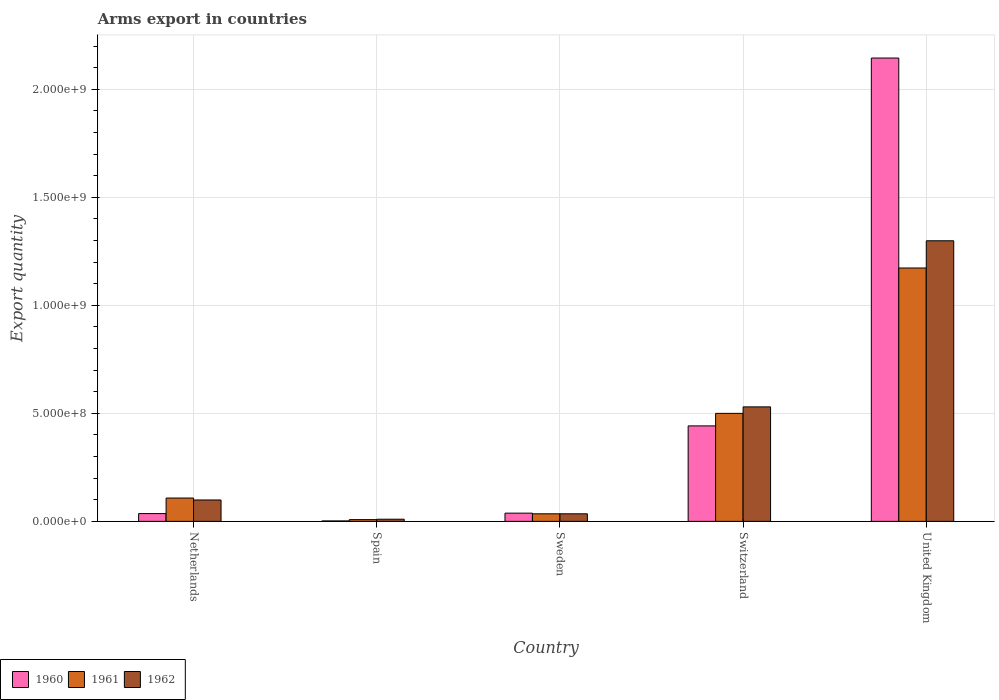How many different coloured bars are there?
Your answer should be compact. 3. How many groups of bars are there?
Provide a short and direct response. 5. Are the number of bars on each tick of the X-axis equal?
Make the answer very short. Yes. What is the label of the 1st group of bars from the left?
Ensure brevity in your answer.  Netherlands. In how many cases, is the number of bars for a given country not equal to the number of legend labels?
Your answer should be very brief. 0. What is the total arms export in 1961 in United Kingdom?
Your response must be concise. 1.17e+09. Across all countries, what is the maximum total arms export in 1962?
Your response must be concise. 1.30e+09. In which country was the total arms export in 1961 maximum?
Your response must be concise. United Kingdom. In which country was the total arms export in 1961 minimum?
Ensure brevity in your answer.  Spain. What is the total total arms export in 1962 in the graph?
Make the answer very short. 1.97e+09. What is the difference between the total arms export in 1960 in Spain and that in Switzerland?
Offer a very short reply. -4.40e+08. What is the difference between the total arms export in 1961 in Switzerland and the total arms export in 1962 in Netherlands?
Offer a terse response. 4.01e+08. What is the average total arms export in 1962 per country?
Your answer should be very brief. 3.95e+08. What is the difference between the total arms export of/in 1960 and total arms export of/in 1962 in Netherlands?
Offer a terse response. -6.30e+07. In how many countries, is the total arms export in 1960 greater than 300000000?
Your response must be concise. 2. What is the ratio of the total arms export in 1960 in Netherlands to that in United Kingdom?
Make the answer very short. 0.02. Is the total arms export in 1961 in Sweden less than that in Switzerland?
Offer a very short reply. Yes. Is the difference between the total arms export in 1960 in Sweden and United Kingdom greater than the difference between the total arms export in 1962 in Sweden and United Kingdom?
Offer a terse response. No. What is the difference between the highest and the second highest total arms export in 1962?
Provide a short and direct response. 7.69e+08. What is the difference between the highest and the lowest total arms export in 1960?
Make the answer very short. 2.14e+09. What does the 2nd bar from the left in Spain represents?
Your answer should be compact. 1961. What does the 1st bar from the right in Sweden represents?
Your answer should be very brief. 1962. Is it the case that in every country, the sum of the total arms export in 1961 and total arms export in 1960 is greater than the total arms export in 1962?
Provide a short and direct response. No. Are all the bars in the graph horizontal?
Your answer should be compact. No. What is the difference between two consecutive major ticks on the Y-axis?
Give a very brief answer. 5.00e+08. Where does the legend appear in the graph?
Provide a short and direct response. Bottom left. What is the title of the graph?
Keep it short and to the point. Arms export in countries. What is the label or title of the X-axis?
Make the answer very short. Country. What is the label or title of the Y-axis?
Your response must be concise. Export quantity. What is the Export quantity of 1960 in Netherlands?
Your answer should be very brief. 3.60e+07. What is the Export quantity of 1961 in Netherlands?
Keep it short and to the point. 1.08e+08. What is the Export quantity of 1962 in Netherlands?
Your answer should be very brief. 9.90e+07. What is the Export quantity of 1960 in Spain?
Ensure brevity in your answer.  2.00e+06. What is the Export quantity in 1960 in Sweden?
Give a very brief answer. 3.80e+07. What is the Export quantity in 1961 in Sweden?
Keep it short and to the point. 3.50e+07. What is the Export quantity in 1962 in Sweden?
Make the answer very short. 3.50e+07. What is the Export quantity in 1960 in Switzerland?
Ensure brevity in your answer.  4.42e+08. What is the Export quantity in 1962 in Switzerland?
Your answer should be compact. 5.30e+08. What is the Export quantity of 1960 in United Kingdom?
Make the answer very short. 2.14e+09. What is the Export quantity in 1961 in United Kingdom?
Ensure brevity in your answer.  1.17e+09. What is the Export quantity of 1962 in United Kingdom?
Offer a terse response. 1.30e+09. Across all countries, what is the maximum Export quantity of 1960?
Ensure brevity in your answer.  2.14e+09. Across all countries, what is the maximum Export quantity in 1961?
Ensure brevity in your answer.  1.17e+09. Across all countries, what is the maximum Export quantity of 1962?
Your answer should be compact. 1.30e+09. Across all countries, what is the minimum Export quantity in 1960?
Your response must be concise. 2.00e+06. Across all countries, what is the minimum Export quantity in 1961?
Give a very brief answer. 8.00e+06. Across all countries, what is the minimum Export quantity in 1962?
Your answer should be very brief. 1.00e+07. What is the total Export quantity in 1960 in the graph?
Provide a succinct answer. 2.66e+09. What is the total Export quantity in 1961 in the graph?
Provide a succinct answer. 1.82e+09. What is the total Export quantity in 1962 in the graph?
Your response must be concise. 1.97e+09. What is the difference between the Export quantity in 1960 in Netherlands and that in Spain?
Keep it short and to the point. 3.40e+07. What is the difference between the Export quantity in 1962 in Netherlands and that in Spain?
Ensure brevity in your answer.  8.90e+07. What is the difference between the Export quantity of 1960 in Netherlands and that in Sweden?
Your answer should be very brief. -2.00e+06. What is the difference between the Export quantity of 1961 in Netherlands and that in Sweden?
Give a very brief answer. 7.30e+07. What is the difference between the Export quantity of 1962 in Netherlands and that in Sweden?
Offer a terse response. 6.40e+07. What is the difference between the Export quantity in 1960 in Netherlands and that in Switzerland?
Provide a short and direct response. -4.06e+08. What is the difference between the Export quantity of 1961 in Netherlands and that in Switzerland?
Provide a short and direct response. -3.92e+08. What is the difference between the Export quantity of 1962 in Netherlands and that in Switzerland?
Provide a succinct answer. -4.31e+08. What is the difference between the Export quantity in 1960 in Netherlands and that in United Kingdom?
Provide a short and direct response. -2.11e+09. What is the difference between the Export quantity of 1961 in Netherlands and that in United Kingdom?
Your answer should be very brief. -1.06e+09. What is the difference between the Export quantity in 1962 in Netherlands and that in United Kingdom?
Give a very brief answer. -1.20e+09. What is the difference between the Export quantity in 1960 in Spain and that in Sweden?
Provide a succinct answer. -3.60e+07. What is the difference between the Export quantity of 1961 in Spain and that in Sweden?
Ensure brevity in your answer.  -2.70e+07. What is the difference between the Export quantity of 1962 in Spain and that in Sweden?
Give a very brief answer. -2.50e+07. What is the difference between the Export quantity in 1960 in Spain and that in Switzerland?
Your answer should be very brief. -4.40e+08. What is the difference between the Export quantity in 1961 in Spain and that in Switzerland?
Your answer should be very brief. -4.92e+08. What is the difference between the Export quantity in 1962 in Spain and that in Switzerland?
Your answer should be very brief. -5.20e+08. What is the difference between the Export quantity in 1960 in Spain and that in United Kingdom?
Offer a terse response. -2.14e+09. What is the difference between the Export quantity of 1961 in Spain and that in United Kingdom?
Make the answer very short. -1.16e+09. What is the difference between the Export quantity of 1962 in Spain and that in United Kingdom?
Provide a short and direct response. -1.29e+09. What is the difference between the Export quantity in 1960 in Sweden and that in Switzerland?
Your response must be concise. -4.04e+08. What is the difference between the Export quantity of 1961 in Sweden and that in Switzerland?
Make the answer very short. -4.65e+08. What is the difference between the Export quantity of 1962 in Sweden and that in Switzerland?
Offer a terse response. -4.95e+08. What is the difference between the Export quantity in 1960 in Sweden and that in United Kingdom?
Your answer should be very brief. -2.11e+09. What is the difference between the Export quantity of 1961 in Sweden and that in United Kingdom?
Provide a succinct answer. -1.14e+09. What is the difference between the Export quantity of 1962 in Sweden and that in United Kingdom?
Keep it short and to the point. -1.26e+09. What is the difference between the Export quantity of 1960 in Switzerland and that in United Kingdom?
Your response must be concise. -1.70e+09. What is the difference between the Export quantity of 1961 in Switzerland and that in United Kingdom?
Offer a terse response. -6.73e+08. What is the difference between the Export quantity of 1962 in Switzerland and that in United Kingdom?
Your answer should be very brief. -7.69e+08. What is the difference between the Export quantity of 1960 in Netherlands and the Export quantity of 1961 in Spain?
Your answer should be compact. 2.80e+07. What is the difference between the Export quantity in 1960 in Netherlands and the Export quantity in 1962 in Spain?
Make the answer very short. 2.60e+07. What is the difference between the Export quantity in 1961 in Netherlands and the Export quantity in 1962 in Spain?
Offer a very short reply. 9.80e+07. What is the difference between the Export quantity in 1960 in Netherlands and the Export quantity in 1961 in Sweden?
Give a very brief answer. 1.00e+06. What is the difference between the Export quantity of 1961 in Netherlands and the Export quantity of 1962 in Sweden?
Your response must be concise. 7.30e+07. What is the difference between the Export quantity of 1960 in Netherlands and the Export quantity of 1961 in Switzerland?
Give a very brief answer. -4.64e+08. What is the difference between the Export quantity in 1960 in Netherlands and the Export quantity in 1962 in Switzerland?
Offer a very short reply. -4.94e+08. What is the difference between the Export quantity of 1961 in Netherlands and the Export quantity of 1962 in Switzerland?
Keep it short and to the point. -4.22e+08. What is the difference between the Export quantity of 1960 in Netherlands and the Export quantity of 1961 in United Kingdom?
Your answer should be compact. -1.14e+09. What is the difference between the Export quantity in 1960 in Netherlands and the Export quantity in 1962 in United Kingdom?
Your answer should be very brief. -1.26e+09. What is the difference between the Export quantity of 1961 in Netherlands and the Export quantity of 1962 in United Kingdom?
Your response must be concise. -1.19e+09. What is the difference between the Export quantity in 1960 in Spain and the Export quantity in 1961 in Sweden?
Your answer should be very brief. -3.30e+07. What is the difference between the Export quantity in 1960 in Spain and the Export quantity in 1962 in Sweden?
Keep it short and to the point. -3.30e+07. What is the difference between the Export quantity in 1961 in Spain and the Export quantity in 1962 in Sweden?
Provide a short and direct response. -2.70e+07. What is the difference between the Export quantity of 1960 in Spain and the Export quantity of 1961 in Switzerland?
Your response must be concise. -4.98e+08. What is the difference between the Export quantity in 1960 in Spain and the Export quantity in 1962 in Switzerland?
Your answer should be compact. -5.28e+08. What is the difference between the Export quantity in 1961 in Spain and the Export quantity in 1962 in Switzerland?
Provide a succinct answer. -5.22e+08. What is the difference between the Export quantity of 1960 in Spain and the Export quantity of 1961 in United Kingdom?
Your response must be concise. -1.17e+09. What is the difference between the Export quantity in 1960 in Spain and the Export quantity in 1962 in United Kingdom?
Your answer should be compact. -1.30e+09. What is the difference between the Export quantity in 1961 in Spain and the Export quantity in 1962 in United Kingdom?
Make the answer very short. -1.29e+09. What is the difference between the Export quantity in 1960 in Sweden and the Export quantity in 1961 in Switzerland?
Ensure brevity in your answer.  -4.62e+08. What is the difference between the Export quantity of 1960 in Sweden and the Export quantity of 1962 in Switzerland?
Provide a short and direct response. -4.92e+08. What is the difference between the Export quantity in 1961 in Sweden and the Export quantity in 1962 in Switzerland?
Offer a very short reply. -4.95e+08. What is the difference between the Export quantity in 1960 in Sweden and the Export quantity in 1961 in United Kingdom?
Offer a very short reply. -1.14e+09. What is the difference between the Export quantity in 1960 in Sweden and the Export quantity in 1962 in United Kingdom?
Offer a terse response. -1.26e+09. What is the difference between the Export quantity in 1961 in Sweden and the Export quantity in 1962 in United Kingdom?
Offer a terse response. -1.26e+09. What is the difference between the Export quantity in 1960 in Switzerland and the Export quantity in 1961 in United Kingdom?
Offer a terse response. -7.31e+08. What is the difference between the Export quantity of 1960 in Switzerland and the Export quantity of 1962 in United Kingdom?
Provide a succinct answer. -8.57e+08. What is the difference between the Export quantity in 1961 in Switzerland and the Export quantity in 1962 in United Kingdom?
Keep it short and to the point. -7.99e+08. What is the average Export quantity of 1960 per country?
Ensure brevity in your answer.  5.33e+08. What is the average Export quantity in 1961 per country?
Your answer should be very brief. 3.65e+08. What is the average Export quantity of 1962 per country?
Your response must be concise. 3.95e+08. What is the difference between the Export quantity in 1960 and Export quantity in 1961 in Netherlands?
Provide a short and direct response. -7.20e+07. What is the difference between the Export quantity of 1960 and Export quantity of 1962 in Netherlands?
Give a very brief answer. -6.30e+07. What is the difference between the Export quantity of 1961 and Export quantity of 1962 in Netherlands?
Keep it short and to the point. 9.00e+06. What is the difference between the Export quantity in 1960 and Export quantity in 1961 in Spain?
Your answer should be very brief. -6.00e+06. What is the difference between the Export quantity of 1960 and Export quantity of 1962 in Spain?
Provide a short and direct response. -8.00e+06. What is the difference between the Export quantity in 1960 and Export quantity in 1961 in Sweden?
Ensure brevity in your answer.  3.00e+06. What is the difference between the Export quantity of 1960 and Export quantity of 1961 in Switzerland?
Provide a succinct answer. -5.80e+07. What is the difference between the Export quantity in 1960 and Export quantity in 1962 in Switzerland?
Your answer should be very brief. -8.80e+07. What is the difference between the Export quantity of 1961 and Export quantity of 1962 in Switzerland?
Offer a terse response. -3.00e+07. What is the difference between the Export quantity of 1960 and Export quantity of 1961 in United Kingdom?
Provide a short and direct response. 9.72e+08. What is the difference between the Export quantity in 1960 and Export quantity in 1962 in United Kingdom?
Your response must be concise. 8.46e+08. What is the difference between the Export quantity in 1961 and Export quantity in 1962 in United Kingdom?
Make the answer very short. -1.26e+08. What is the ratio of the Export quantity in 1961 in Netherlands to that in Spain?
Ensure brevity in your answer.  13.5. What is the ratio of the Export quantity in 1961 in Netherlands to that in Sweden?
Offer a terse response. 3.09. What is the ratio of the Export quantity in 1962 in Netherlands to that in Sweden?
Keep it short and to the point. 2.83. What is the ratio of the Export quantity in 1960 in Netherlands to that in Switzerland?
Keep it short and to the point. 0.08. What is the ratio of the Export quantity in 1961 in Netherlands to that in Switzerland?
Provide a short and direct response. 0.22. What is the ratio of the Export quantity of 1962 in Netherlands to that in Switzerland?
Give a very brief answer. 0.19. What is the ratio of the Export quantity in 1960 in Netherlands to that in United Kingdom?
Ensure brevity in your answer.  0.02. What is the ratio of the Export quantity in 1961 in Netherlands to that in United Kingdom?
Your answer should be compact. 0.09. What is the ratio of the Export quantity of 1962 in Netherlands to that in United Kingdom?
Your answer should be very brief. 0.08. What is the ratio of the Export quantity in 1960 in Spain to that in Sweden?
Offer a terse response. 0.05. What is the ratio of the Export quantity of 1961 in Spain to that in Sweden?
Provide a short and direct response. 0.23. What is the ratio of the Export quantity in 1962 in Spain to that in Sweden?
Keep it short and to the point. 0.29. What is the ratio of the Export quantity of 1960 in Spain to that in Switzerland?
Your answer should be very brief. 0. What is the ratio of the Export quantity of 1961 in Spain to that in Switzerland?
Provide a succinct answer. 0.02. What is the ratio of the Export quantity of 1962 in Spain to that in Switzerland?
Provide a short and direct response. 0.02. What is the ratio of the Export quantity of 1960 in Spain to that in United Kingdom?
Provide a short and direct response. 0. What is the ratio of the Export quantity of 1961 in Spain to that in United Kingdom?
Your answer should be very brief. 0.01. What is the ratio of the Export quantity in 1962 in Spain to that in United Kingdom?
Provide a short and direct response. 0.01. What is the ratio of the Export quantity of 1960 in Sweden to that in Switzerland?
Your answer should be very brief. 0.09. What is the ratio of the Export quantity in 1961 in Sweden to that in Switzerland?
Your answer should be very brief. 0.07. What is the ratio of the Export quantity in 1962 in Sweden to that in Switzerland?
Your answer should be very brief. 0.07. What is the ratio of the Export quantity in 1960 in Sweden to that in United Kingdom?
Your answer should be very brief. 0.02. What is the ratio of the Export quantity of 1961 in Sweden to that in United Kingdom?
Offer a very short reply. 0.03. What is the ratio of the Export quantity in 1962 in Sweden to that in United Kingdom?
Provide a succinct answer. 0.03. What is the ratio of the Export quantity of 1960 in Switzerland to that in United Kingdom?
Make the answer very short. 0.21. What is the ratio of the Export quantity in 1961 in Switzerland to that in United Kingdom?
Give a very brief answer. 0.43. What is the ratio of the Export quantity in 1962 in Switzerland to that in United Kingdom?
Provide a short and direct response. 0.41. What is the difference between the highest and the second highest Export quantity of 1960?
Offer a terse response. 1.70e+09. What is the difference between the highest and the second highest Export quantity of 1961?
Ensure brevity in your answer.  6.73e+08. What is the difference between the highest and the second highest Export quantity in 1962?
Your response must be concise. 7.69e+08. What is the difference between the highest and the lowest Export quantity of 1960?
Your answer should be very brief. 2.14e+09. What is the difference between the highest and the lowest Export quantity in 1961?
Give a very brief answer. 1.16e+09. What is the difference between the highest and the lowest Export quantity in 1962?
Your response must be concise. 1.29e+09. 